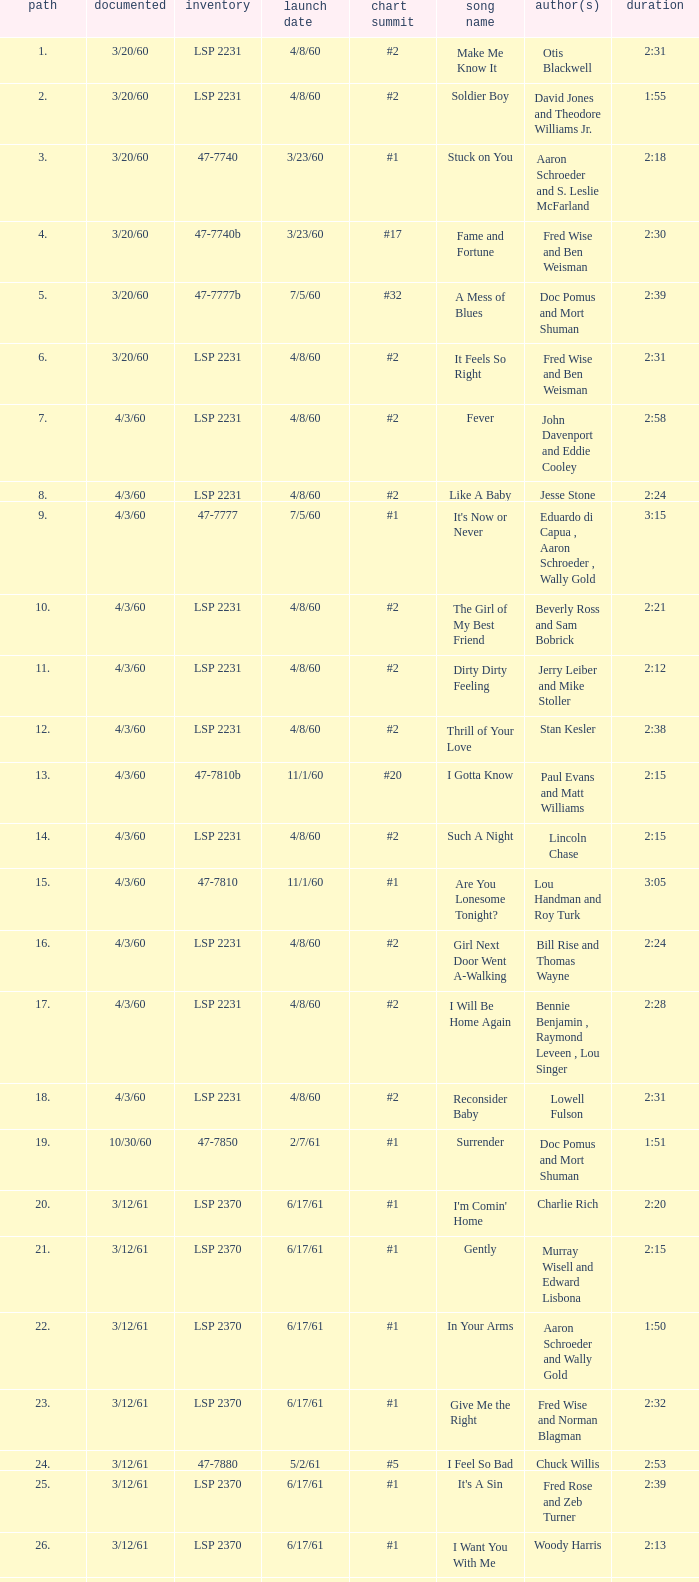On songs with track numbers smaller than number 17 and catalogues of LSP 2231, who are the writer(s)? Otis Blackwell, David Jones and Theodore Williams Jr., Fred Wise and Ben Weisman, John Davenport and Eddie Cooley, Jesse Stone, Beverly Ross and Sam Bobrick, Jerry Leiber and Mike Stoller, Stan Kesler, Lincoln Chase, Bill Rise and Thomas Wayne. 